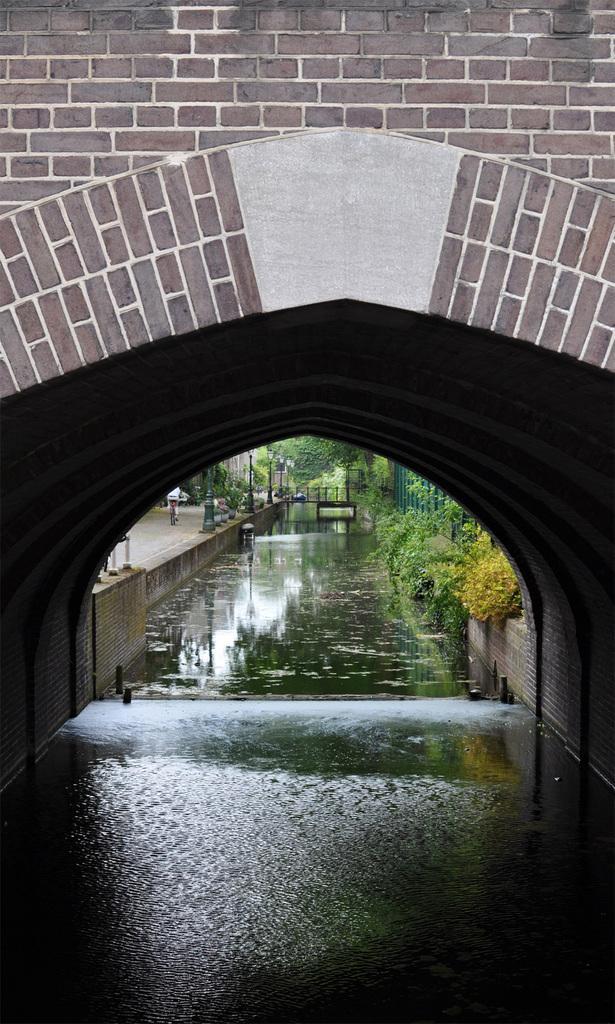How would you summarize this image in a sentence or two? In this image we can able to see a bridge which is built with bricks and we can able so see some bushes here, and there is a road and there is a person who is riding cycle and there is a lake flowing here. 